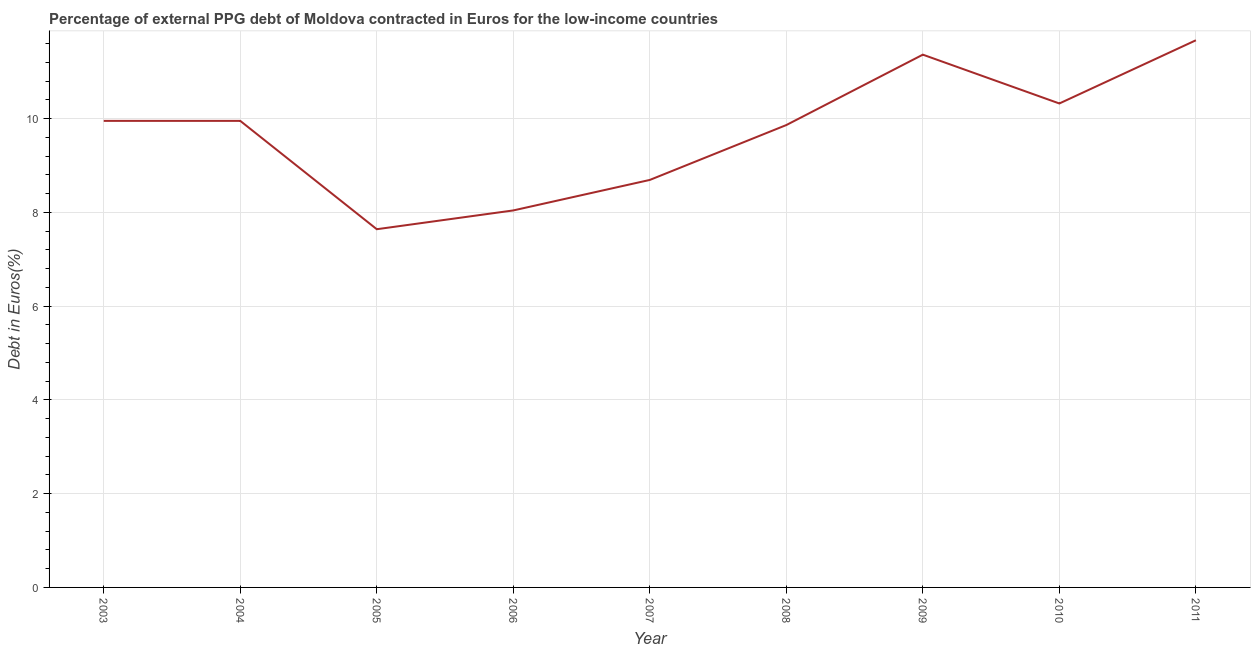What is the currency composition of ppg debt in 2005?
Make the answer very short. 7.64. Across all years, what is the maximum currency composition of ppg debt?
Your response must be concise. 11.67. Across all years, what is the minimum currency composition of ppg debt?
Your answer should be compact. 7.64. In which year was the currency composition of ppg debt maximum?
Make the answer very short. 2011. What is the sum of the currency composition of ppg debt?
Your answer should be very brief. 87.49. What is the difference between the currency composition of ppg debt in 2008 and 2011?
Offer a terse response. -1.81. What is the average currency composition of ppg debt per year?
Give a very brief answer. 9.72. What is the median currency composition of ppg debt?
Ensure brevity in your answer.  9.95. What is the ratio of the currency composition of ppg debt in 2006 to that in 2007?
Provide a succinct answer. 0.93. What is the difference between the highest and the second highest currency composition of ppg debt?
Your response must be concise. 0.31. Is the sum of the currency composition of ppg debt in 2003 and 2005 greater than the maximum currency composition of ppg debt across all years?
Make the answer very short. Yes. What is the difference between the highest and the lowest currency composition of ppg debt?
Your response must be concise. 4.03. What is the difference between two consecutive major ticks on the Y-axis?
Offer a terse response. 2. Are the values on the major ticks of Y-axis written in scientific E-notation?
Offer a very short reply. No. What is the title of the graph?
Ensure brevity in your answer.  Percentage of external PPG debt of Moldova contracted in Euros for the low-income countries. What is the label or title of the X-axis?
Your answer should be very brief. Year. What is the label or title of the Y-axis?
Your answer should be very brief. Debt in Euros(%). What is the Debt in Euros(%) in 2003?
Your answer should be very brief. 9.95. What is the Debt in Euros(%) of 2004?
Make the answer very short. 9.95. What is the Debt in Euros(%) in 2005?
Make the answer very short. 7.64. What is the Debt in Euros(%) in 2006?
Provide a succinct answer. 8.04. What is the Debt in Euros(%) in 2007?
Give a very brief answer. 8.69. What is the Debt in Euros(%) in 2008?
Ensure brevity in your answer.  9.86. What is the Debt in Euros(%) of 2009?
Your response must be concise. 11.36. What is the Debt in Euros(%) in 2010?
Give a very brief answer. 10.32. What is the Debt in Euros(%) in 2011?
Provide a succinct answer. 11.67. What is the difference between the Debt in Euros(%) in 2003 and 2004?
Your response must be concise. 0. What is the difference between the Debt in Euros(%) in 2003 and 2005?
Provide a succinct answer. 2.31. What is the difference between the Debt in Euros(%) in 2003 and 2006?
Give a very brief answer. 1.91. What is the difference between the Debt in Euros(%) in 2003 and 2007?
Provide a short and direct response. 1.26. What is the difference between the Debt in Euros(%) in 2003 and 2008?
Offer a very short reply. 0.09. What is the difference between the Debt in Euros(%) in 2003 and 2009?
Provide a succinct answer. -1.41. What is the difference between the Debt in Euros(%) in 2003 and 2010?
Provide a succinct answer. -0.37. What is the difference between the Debt in Euros(%) in 2003 and 2011?
Provide a short and direct response. -1.72. What is the difference between the Debt in Euros(%) in 2004 and 2005?
Make the answer very short. 2.31. What is the difference between the Debt in Euros(%) in 2004 and 2006?
Provide a short and direct response. 1.91. What is the difference between the Debt in Euros(%) in 2004 and 2007?
Keep it short and to the point. 1.26. What is the difference between the Debt in Euros(%) in 2004 and 2008?
Provide a succinct answer. 0.09. What is the difference between the Debt in Euros(%) in 2004 and 2009?
Make the answer very short. -1.41. What is the difference between the Debt in Euros(%) in 2004 and 2010?
Your answer should be compact. -0.37. What is the difference between the Debt in Euros(%) in 2004 and 2011?
Provide a succinct answer. -1.72. What is the difference between the Debt in Euros(%) in 2005 and 2006?
Offer a terse response. -0.4. What is the difference between the Debt in Euros(%) in 2005 and 2007?
Keep it short and to the point. -1.05. What is the difference between the Debt in Euros(%) in 2005 and 2008?
Provide a short and direct response. -2.22. What is the difference between the Debt in Euros(%) in 2005 and 2009?
Keep it short and to the point. -3.72. What is the difference between the Debt in Euros(%) in 2005 and 2010?
Offer a terse response. -2.68. What is the difference between the Debt in Euros(%) in 2005 and 2011?
Your response must be concise. -4.03. What is the difference between the Debt in Euros(%) in 2006 and 2007?
Offer a very short reply. -0.65. What is the difference between the Debt in Euros(%) in 2006 and 2008?
Ensure brevity in your answer.  -1.82. What is the difference between the Debt in Euros(%) in 2006 and 2009?
Provide a succinct answer. -3.32. What is the difference between the Debt in Euros(%) in 2006 and 2010?
Give a very brief answer. -2.28. What is the difference between the Debt in Euros(%) in 2006 and 2011?
Keep it short and to the point. -3.63. What is the difference between the Debt in Euros(%) in 2007 and 2008?
Offer a terse response. -1.17. What is the difference between the Debt in Euros(%) in 2007 and 2009?
Give a very brief answer. -2.67. What is the difference between the Debt in Euros(%) in 2007 and 2010?
Offer a very short reply. -1.63. What is the difference between the Debt in Euros(%) in 2007 and 2011?
Provide a short and direct response. -2.98. What is the difference between the Debt in Euros(%) in 2008 and 2009?
Provide a short and direct response. -1.5. What is the difference between the Debt in Euros(%) in 2008 and 2010?
Your response must be concise. -0.46. What is the difference between the Debt in Euros(%) in 2008 and 2011?
Your answer should be very brief. -1.81. What is the difference between the Debt in Euros(%) in 2009 and 2010?
Give a very brief answer. 1.04. What is the difference between the Debt in Euros(%) in 2009 and 2011?
Your answer should be very brief. -0.31. What is the difference between the Debt in Euros(%) in 2010 and 2011?
Your answer should be very brief. -1.35. What is the ratio of the Debt in Euros(%) in 2003 to that in 2005?
Provide a succinct answer. 1.3. What is the ratio of the Debt in Euros(%) in 2003 to that in 2006?
Provide a succinct answer. 1.24. What is the ratio of the Debt in Euros(%) in 2003 to that in 2007?
Give a very brief answer. 1.15. What is the ratio of the Debt in Euros(%) in 2003 to that in 2009?
Offer a terse response. 0.88. What is the ratio of the Debt in Euros(%) in 2003 to that in 2010?
Provide a succinct answer. 0.96. What is the ratio of the Debt in Euros(%) in 2003 to that in 2011?
Provide a succinct answer. 0.85. What is the ratio of the Debt in Euros(%) in 2004 to that in 2005?
Ensure brevity in your answer.  1.3. What is the ratio of the Debt in Euros(%) in 2004 to that in 2006?
Provide a succinct answer. 1.24. What is the ratio of the Debt in Euros(%) in 2004 to that in 2007?
Your answer should be very brief. 1.15. What is the ratio of the Debt in Euros(%) in 2004 to that in 2009?
Keep it short and to the point. 0.88. What is the ratio of the Debt in Euros(%) in 2004 to that in 2011?
Provide a succinct answer. 0.85. What is the ratio of the Debt in Euros(%) in 2005 to that in 2007?
Provide a succinct answer. 0.88. What is the ratio of the Debt in Euros(%) in 2005 to that in 2008?
Give a very brief answer. 0.78. What is the ratio of the Debt in Euros(%) in 2005 to that in 2009?
Ensure brevity in your answer.  0.67. What is the ratio of the Debt in Euros(%) in 2005 to that in 2010?
Your response must be concise. 0.74. What is the ratio of the Debt in Euros(%) in 2005 to that in 2011?
Provide a short and direct response. 0.66. What is the ratio of the Debt in Euros(%) in 2006 to that in 2007?
Your answer should be compact. 0.93. What is the ratio of the Debt in Euros(%) in 2006 to that in 2008?
Your answer should be very brief. 0.81. What is the ratio of the Debt in Euros(%) in 2006 to that in 2009?
Offer a terse response. 0.71. What is the ratio of the Debt in Euros(%) in 2006 to that in 2010?
Provide a short and direct response. 0.78. What is the ratio of the Debt in Euros(%) in 2006 to that in 2011?
Provide a short and direct response. 0.69. What is the ratio of the Debt in Euros(%) in 2007 to that in 2008?
Offer a very short reply. 0.88. What is the ratio of the Debt in Euros(%) in 2007 to that in 2009?
Ensure brevity in your answer.  0.77. What is the ratio of the Debt in Euros(%) in 2007 to that in 2010?
Provide a short and direct response. 0.84. What is the ratio of the Debt in Euros(%) in 2007 to that in 2011?
Give a very brief answer. 0.74. What is the ratio of the Debt in Euros(%) in 2008 to that in 2009?
Provide a succinct answer. 0.87. What is the ratio of the Debt in Euros(%) in 2008 to that in 2010?
Make the answer very short. 0.95. What is the ratio of the Debt in Euros(%) in 2008 to that in 2011?
Provide a succinct answer. 0.84. What is the ratio of the Debt in Euros(%) in 2009 to that in 2010?
Offer a terse response. 1.1. What is the ratio of the Debt in Euros(%) in 2009 to that in 2011?
Provide a succinct answer. 0.97. What is the ratio of the Debt in Euros(%) in 2010 to that in 2011?
Your answer should be very brief. 0.88. 